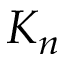<formula> <loc_0><loc_0><loc_500><loc_500>K _ { n }</formula> 